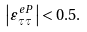Convert formula to latex. <formula><loc_0><loc_0><loc_500><loc_500>\left | \varepsilon _ { \tau \tau } ^ { e P } \right | < 0 . 5 .</formula> 